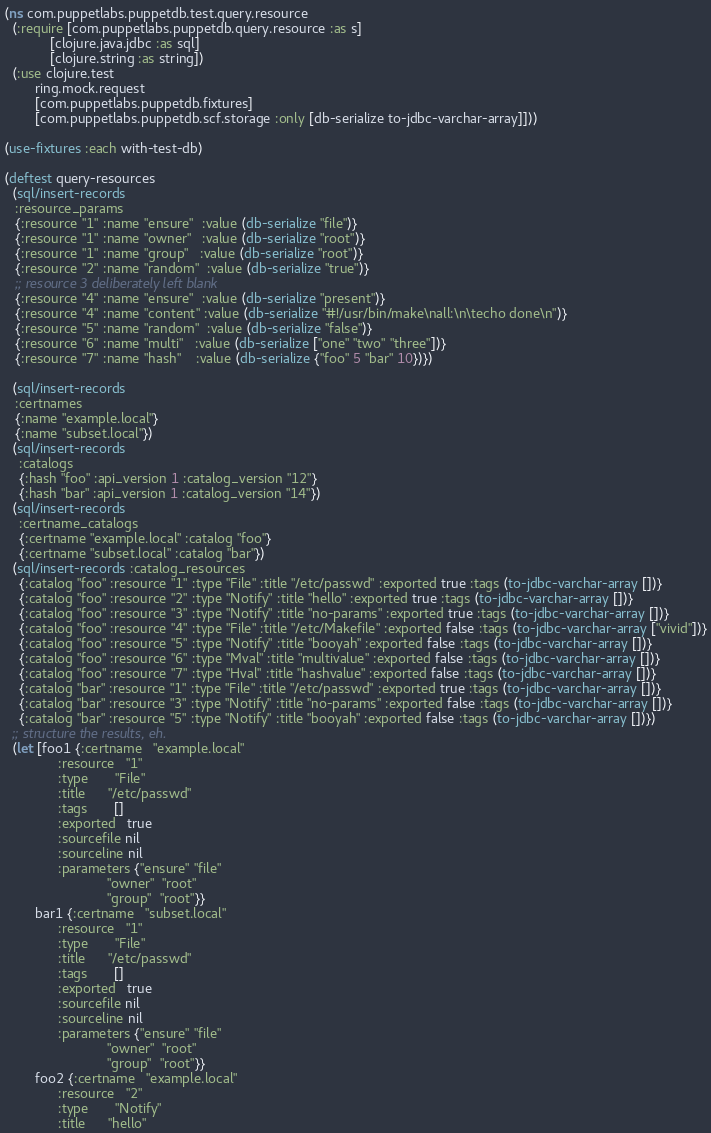<code> <loc_0><loc_0><loc_500><loc_500><_Clojure_>(ns com.puppetlabs.puppetdb.test.query.resource
  (:require [com.puppetlabs.puppetdb.query.resource :as s]
            [clojure.java.jdbc :as sql]
            [clojure.string :as string])
  (:use clojure.test
        ring.mock.request
        [com.puppetlabs.puppetdb.fixtures]
        [com.puppetlabs.puppetdb.scf.storage :only [db-serialize to-jdbc-varchar-array]]))

(use-fixtures :each with-test-db)

(deftest query-resources
  (sql/insert-records
   :resource_params
   {:resource "1" :name "ensure"  :value (db-serialize "file")}
   {:resource "1" :name "owner"   :value (db-serialize "root")}
   {:resource "1" :name "group"   :value (db-serialize "root")}
   {:resource "2" :name "random"  :value (db-serialize "true")}
   ;; resource 3 deliberately left blank
   {:resource "4" :name "ensure"  :value (db-serialize "present")}
   {:resource "4" :name "content" :value (db-serialize "#!/usr/bin/make\nall:\n\techo done\n")}
   {:resource "5" :name "random"  :value (db-serialize "false")}
   {:resource "6" :name "multi"   :value (db-serialize ["one" "two" "three"])}
   {:resource "7" :name "hash"    :value (db-serialize {"foo" 5 "bar" 10})})

  (sql/insert-records
   :certnames
   {:name "example.local"}
   {:name "subset.local"})
  (sql/insert-records
    :catalogs
    {:hash "foo" :api_version 1 :catalog_version "12"}
    {:hash "bar" :api_version 1 :catalog_version "14"})
  (sql/insert-records
    :certname_catalogs
    {:certname "example.local" :catalog "foo"}
    {:certname "subset.local" :catalog "bar"})
  (sql/insert-records :catalog_resources
    {:catalog "foo" :resource "1" :type "File" :title "/etc/passwd" :exported true :tags (to-jdbc-varchar-array [])}
    {:catalog "foo" :resource "2" :type "Notify" :title "hello" :exported true :tags (to-jdbc-varchar-array [])}
    {:catalog "foo" :resource "3" :type "Notify" :title "no-params" :exported true :tags (to-jdbc-varchar-array [])}
    {:catalog "foo" :resource "4" :type "File" :title "/etc/Makefile" :exported false :tags (to-jdbc-varchar-array ["vivid"])}
    {:catalog "foo" :resource "5" :type "Notify" :title "booyah" :exported false :tags (to-jdbc-varchar-array [])}
    {:catalog "foo" :resource "6" :type "Mval" :title "multivalue" :exported false :tags (to-jdbc-varchar-array [])}
    {:catalog "foo" :resource "7" :type "Hval" :title "hashvalue" :exported false :tags (to-jdbc-varchar-array [])}
    {:catalog "bar" :resource "1" :type "File" :title "/etc/passwd" :exported true :tags (to-jdbc-varchar-array [])}
    {:catalog "bar" :resource "3" :type "Notify" :title "no-params" :exported false :tags (to-jdbc-varchar-array [])}
    {:catalog "bar" :resource "5" :type "Notify" :title "booyah" :exported false :tags (to-jdbc-varchar-array [])})
  ;; structure the results, eh.
  (let [foo1 {:certname   "example.local"
              :resource   "1"
              :type       "File"
              :title      "/etc/passwd"
              :tags       []
              :exported   true
              :sourcefile nil
              :sourceline nil
              :parameters {"ensure" "file"
                           "owner"  "root"
                           "group"  "root"}}
        bar1 {:certname   "subset.local"
              :resource   "1"
              :type       "File"
              :title      "/etc/passwd"
              :tags       []
              :exported   true
              :sourcefile nil
              :sourceline nil
              :parameters {"ensure" "file"
                           "owner"  "root"
                           "group"  "root"}}
        foo2 {:certname   "example.local"
              :resource   "2"
              :type       "Notify"
              :title      "hello"</code> 